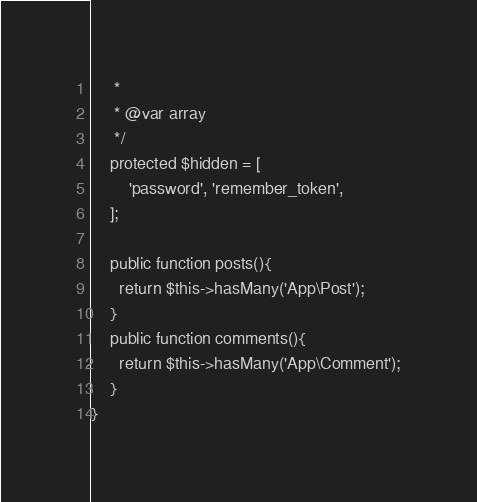<code> <loc_0><loc_0><loc_500><loc_500><_PHP_>     *
     * @var array
     */
    protected $hidden = [
        'password', 'remember_token',
    ];

    public function posts(){
      return $this->hasMany('App\Post');
    }
    public function comments(){
      return $this->hasMany('App\Comment');
    }
}
</code> 